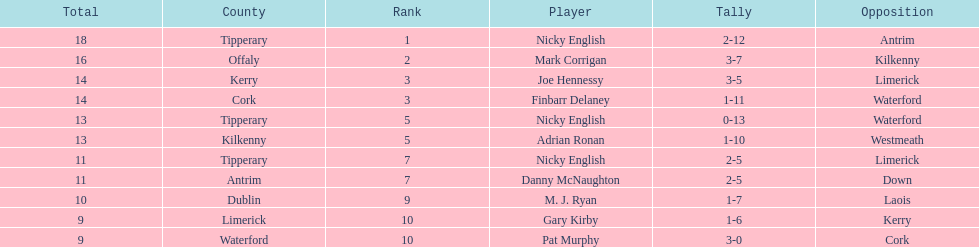What is the least total on the list? 9. 